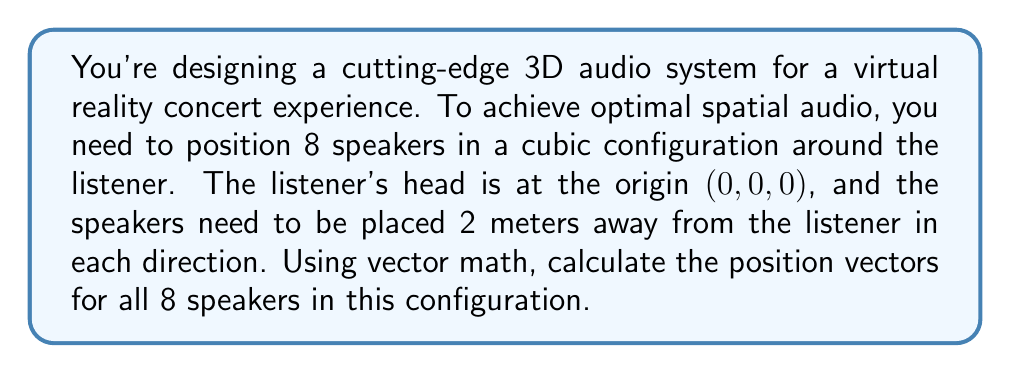Can you answer this question? To solve this problem, we need to consider the following steps:

1) In a cubic configuration, the speakers will be placed at the corners of a cube centered at the origin.

2) Since the speakers need to be 2 meters away from the listener in each direction, the coordinates of each speaker will be either +2 or -2 for each axis.

3) We can represent each speaker position as a vector with three components: (x, y, z).

4) The 8 possible combinations of +2 and -2 for x, y, and z will give us the positions of all 8 speakers.

Let's list out these combinations:

1. $(+2, +2, +2)$
2. $(+2, +2, -2)$
3. $(+2, -2, +2)$
4. $(+2, -2, -2)$
5. $(-2, +2, +2)$
6. $(-2, +2, -2)$
7. $(-2, -2, +2)$
8. $(-2, -2, -2)$

In vector notation, these position vectors can be written as:

1. $\vec{v_1} = 2\hat{i} + 2\hat{j} + 2\hat{k}$
2. $\vec{v_2} = 2\hat{i} + 2\hat{j} - 2\hat{k}$
3. $\vec{v_3} = 2\hat{i} - 2\hat{j} + 2\hat{k}$
4. $\vec{v_4} = 2\hat{i} - 2\hat{j} - 2\hat{k}$
5. $\vec{v_5} = -2\hat{i} + 2\hat{j} + 2\hat{k}$
6. $\vec{v_6} = -2\hat{i} + 2\hat{j} - 2\hat{k}$
7. $\vec{v_7} = -2\hat{i} - 2\hat{j} + 2\hat{k}$
8. $\vec{v_8} = -2\hat{i} - 2\hat{j} - 2\hat{k}$

Where $\hat{i}$, $\hat{j}$, and $\hat{k}$ are the unit vectors in the x, y, and z directions respectively.

To verify that these positions are indeed 2 meters away from the listener at (0, 0, 0), we can calculate the magnitude of any of these vectors:

$$|\vec{v}| = \sqrt{(\pm2)^2 + (\pm2)^2 + (\pm2)^2} = \sqrt{4 + 4 + 4} = \sqrt{12} = 2\sqrt{3} \approx 3.46$$

This confirms that each speaker is positioned $2\sqrt{3}$ meters from the origin, which is the diagonal distance in a cube with side length 4 meters.
Answer: The position vectors for the 8 speakers are:

1. $\vec{v_1} = 2\hat{i} + 2\hat{j} + 2\hat{k}$
2. $\vec{v_2} = 2\hat{i} + 2\hat{j} - 2\hat{k}$
3. $\vec{v_3} = 2\hat{i} - 2\hat{j} + 2\hat{k}$
4. $\vec{v_4} = 2\hat{i} - 2\hat{j} - 2\hat{k}$
5. $\vec{v_5} = -2\hat{i} + 2\hat{j} + 2\hat{k}$
6. $\vec{v_6} = -2\hat{i} + 2\hat{j} - 2\hat{k}$
7. $\vec{v_7} = -2\hat{i} - 2\hat{j} + 2\hat{k}$
8. $\vec{v_8} = -2\hat{i} - 2\hat{j} - 2\hat{k}$ 